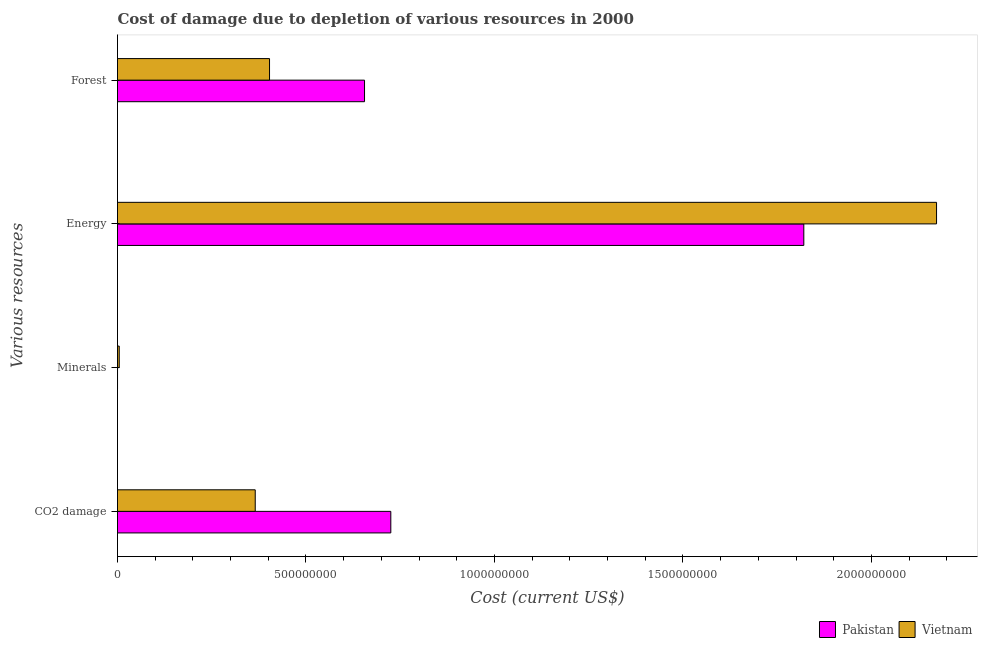How many bars are there on the 3rd tick from the top?
Offer a very short reply. 2. How many bars are there on the 4th tick from the bottom?
Provide a short and direct response. 2. What is the label of the 3rd group of bars from the top?
Ensure brevity in your answer.  Minerals. What is the cost of damage due to depletion of energy in Vietnam?
Your answer should be compact. 2.17e+09. Across all countries, what is the maximum cost of damage due to depletion of coal?
Make the answer very short. 7.25e+08. Across all countries, what is the minimum cost of damage due to depletion of coal?
Offer a terse response. 3.65e+08. In which country was the cost of damage due to depletion of energy minimum?
Keep it short and to the point. Pakistan. What is the total cost of damage due to depletion of minerals in the graph?
Make the answer very short. 4.66e+06. What is the difference between the cost of damage due to depletion of coal in Pakistan and that in Vietnam?
Offer a very short reply. 3.60e+08. What is the difference between the cost of damage due to depletion of forests in Pakistan and the cost of damage due to depletion of minerals in Vietnam?
Provide a succinct answer. 6.51e+08. What is the average cost of damage due to depletion of energy per country?
Provide a short and direct response. 2.00e+09. What is the difference between the cost of damage due to depletion of coal and cost of damage due to depletion of forests in Pakistan?
Provide a short and direct response. 6.97e+07. In how many countries, is the cost of damage due to depletion of energy greater than 1700000000 US$?
Give a very brief answer. 2. What is the ratio of the cost of damage due to depletion of coal in Pakistan to that in Vietnam?
Provide a succinct answer. 1.98. Is the cost of damage due to depletion of energy in Pakistan less than that in Vietnam?
Provide a short and direct response. Yes. Is the difference between the cost of damage due to depletion of coal in Vietnam and Pakistan greater than the difference between the cost of damage due to depletion of forests in Vietnam and Pakistan?
Your answer should be compact. No. What is the difference between the highest and the second highest cost of damage due to depletion of forests?
Provide a short and direct response. 2.52e+08. What is the difference between the highest and the lowest cost of damage due to depletion of minerals?
Your answer should be compact. 4.55e+06. Is the sum of the cost of damage due to depletion of energy in Vietnam and Pakistan greater than the maximum cost of damage due to depletion of coal across all countries?
Keep it short and to the point. Yes. Is it the case that in every country, the sum of the cost of damage due to depletion of energy and cost of damage due to depletion of minerals is greater than the sum of cost of damage due to depletion of coal and cost of damage due to depletion of forests?
Offer a terse response. Yes. What does the 2nd bar from the bottom in CO2 damage represents?
Your answer should be very brief. Vietnam. How many bars are there?
Provide a succinct answer. 8. Are all the bars in the graph horizontal?
Offer a terse response. Yes. How many countries are there in the graph?
Make the answer very short. 2. What is the difference between two consecutive major ticks on the X-axis?
Offer a very short reply. 5.00e+08. Are the values on the major ticks of X-axis written in scientific E-notation?
Ensure brevity in your answer.  No. Does the graph contain any zero values?
Offer a very short reply. No. What is the title of the graph?
Make the answer very short. Cost of damage due to depletion of various resources in 2000 . What is the label or title of the X-axis?
Give a very brief answer. Cost (current US$). What is the label or title of the Y-axis?
Provide a short and direct response. Various resources. What is the Cost (current US$) in Pakistan in CO2 damage?
Offer a terse response. 7.25e+08. What is the Cost (current US$) of Vietnam in CO2 damage?
Ensure brevity in your answer.  3.65e+08. What is the Cost (current US$) in Pakistan in Minerals?
Your answer should be very brief. 5.47e+04. What is the Cost (current US$) of Vietnam in Minerals?
Ensure brevity in your answer.  4.61e+06. What is the Cost (current US$) in Pakistan in Energy?
Your response must be concise. 1.82e+09. What is the Cost (current US$) in Vietnam in Energy?
Make the answer very short. 2.17e+09. What is the Cost (current US$) in Pakistan in Forest?
Your answer should be compact. 6.55e+08. What is the Cost (current US$) of Vietnam in Forest?
Your response must be concise. 4.03e+08. Across all Various resources, what is the maximum Cost (current US$) in Pakistan?
Your response must be concise. 1.82e+09. Across all Various resources, what is the maximum Cost (current US$) in Vietnam?
Give a very brief answer. 2.17e+09. Across all Various resources, what is the minimum Cost (current US$) in Pakistan?
Your response must be concise. 5.47e+04. Across all Various resources, what is the minimum Cost (current US$) of Vietnam?
Offer a very short reply. 4.61e+06. What is the total Cost (current US$) in Pakistan in the graph?
Your answer should be very brief. 3.20e+09. What is the total Cost (current US$) in Vietnam in the graph?
Provide a short and direct response. 2.95e+09. What is the difference between the Cost (current US$) of Pakistan in CO2 damage and that in Minerals?
Your answer should be very brief. 7.25e+08. What is the difference between the Cost (current US$) of Vietnam in CO2 damage and that in Minerals?
Keep it short and to the point. 3.61e+08. What is the difference between the Cost (current US$) in Pakistan in CO2 damage and that in Energy?
Give a very brief answer. -1.10e+09. What is the difference between the Cost (current US$) in Vietnam in CO2 damage and that in Energy?
Provide a short and direct response. -1.81e+09. What is the difference between the Cost (current US$) in Pakistan in CO2 damage and that in Forest?
Provide a succinct answer. 6.97e+07. What is the difference between the Cost (current US$) in Vietnam in CO2 damage and that in Forest?
Provide a succinct answer. -3.79e+07. What is the difference between the Cost (current US$) of Pakistan in Minerals and that in Energy?
Your answer should be very brief. -1.82e+09. What is the difference between the Cost (current US$) of Vietnam in Minerals and that in Energy?
Your answer should be very brief. -2.17e+09. What is the difference between the Cost (current US$) in Pakistan in Minerals and that in Forest?
Your answer should be compact. -6.55e+08. What is the difference between the Cost (current US$) in Vietnam in Minerals and that in Forest?
Your answer should be compact. -3.99e+08. What is the difference between the Cost (current US$) in Pakistan in Energy and that in Forest?
Keep it short and to the point. 1.17e+09. What is the difference between the Cost (current US$) in Vietnam in Energy and that in Forest?
Offer a terse response. 1.77e+09. What is the difference between the Cost (current US$) in Pakistan in CO2 damage and the Cost (current US$) in Vietnam in Minerals?
Offer a terse response. 7.20e+08. What is the difference between the Cost (current US$) of Pakistan in CO2 damage and the Cost (current US$) of Vietnam in Energy?
Your answer should be very brief. -1.45e+09. What is the difference between the Cost (current US$) of Pakistan in CO2 damage and the Cost (current US$) of Vietnam in Forest?
Offer a very short reply. 3.22e+08. What is the difference between the Cost (current US$) of Pakistan in Minerals and the Cost (current US$) of Vietnam in Energy?
Your response must be concise. -2.17e+09. What is the difference between the Cost (current US$) in Pakistan in Minerals and the Cost (current US$) in Vietnam in Forest?
Keep it short and to the point. -4.03e+08. What is the difference between the Cost (current US$) of Pakistan in Energy and the Cost (current US$) of Vietnam in Forest?
Give a very brief answer. 1.42e+09. What is the average Cost (current US$) of Pakistan per Various resources?
Give a very brief answer. 8.00e+08. What is the average Cost (current US$) in Vietnam per Various resources?
Give a very brief answer. 7.36e+08. What is the difference between the Cost (current US$) in Pakistan and Cost (current US$) in Vietnam in CO2 damage?
Give a very brief answer. 3.60e+08. What is the difference between the Cost (current US$) in Pakistan and Cost (current US$) in Vietnam in Minerals?
Your answer should be compact. -4.55e+06. What is the difference between the Cost (current US$) in Pakistan and Cost (current US$) in Vietnam in Energy?
Provide a short and direct response. -3.52e+08. What is the difference between the Cost (current US$) in Pakistan and Cost (current US$) in Vietnam in Forest?
Offer a very short reply. 2.52e+08. What is the ratio of the Cost (current US$) in Pakistan in CO2 damage to that in Minerals?
Ensure brevity in your answer.  1.32e+04. What is the ratio of the Cost (current US$) of Vietnam in CO2 damage to that in Minerals?
Ensure brevity in your answer.  79.33. What is the ratio of the Cost (current US$) in Pakistan in CO2 damage to that in Energy?
Provide a short and direct response. 0.4. What is the ratio of the Cost (current US$) in Vietnam in CO2 damage to that in Energy?
Your answer should be very brief. 0.17. What is the ratio of the Cost (current US$) of Pakistan in CO2 damage to that in Forest?
Provide a short and direct response. 1.11. What is the ratio of the Cost (current US$) of Vietnam in CO2 damage to that in Forest?
Your answer should be compact. 0.91. What is the ratio of the Cost (current US$) in Pakistan in Minerals to that in Energy?
Your response must be concise. 0. What is the ratio of the Cost (current US$) in Vietnam in Minerals to that in Energy?
Your answer should be very brief. 0. What is the ratio of the Cost (current US$) of Vietnam in Minerals to that in Forest?
Make the answer very short. 0.01. What is the ratio of the Cost (current US$) in Pakistan in Energy to that in Forest?
Provide a succinct answer. 2.78. What is the ratio of the Cost (current US$) of Vietnam in Energy to that in Forest?
Make the answer very short. 5.39. What is the difference between the highest and the second highest Cost (current US$) in Pakistan?
Your answer should be very brief. 1.10e+09. What is the difference between the highest and the second highest Cost (current US$) in Vietnam?
Give a very brief answer. 1.77e+09. What is the difference between the highest and the lowest Cost (current US$) in Pakistan?
Provide a short and direct response. 1.82e+09. What is the difference between the highest and the lowest Cost (current US$) of Vietnam?
Your response must be concise. 2.17e+09. 